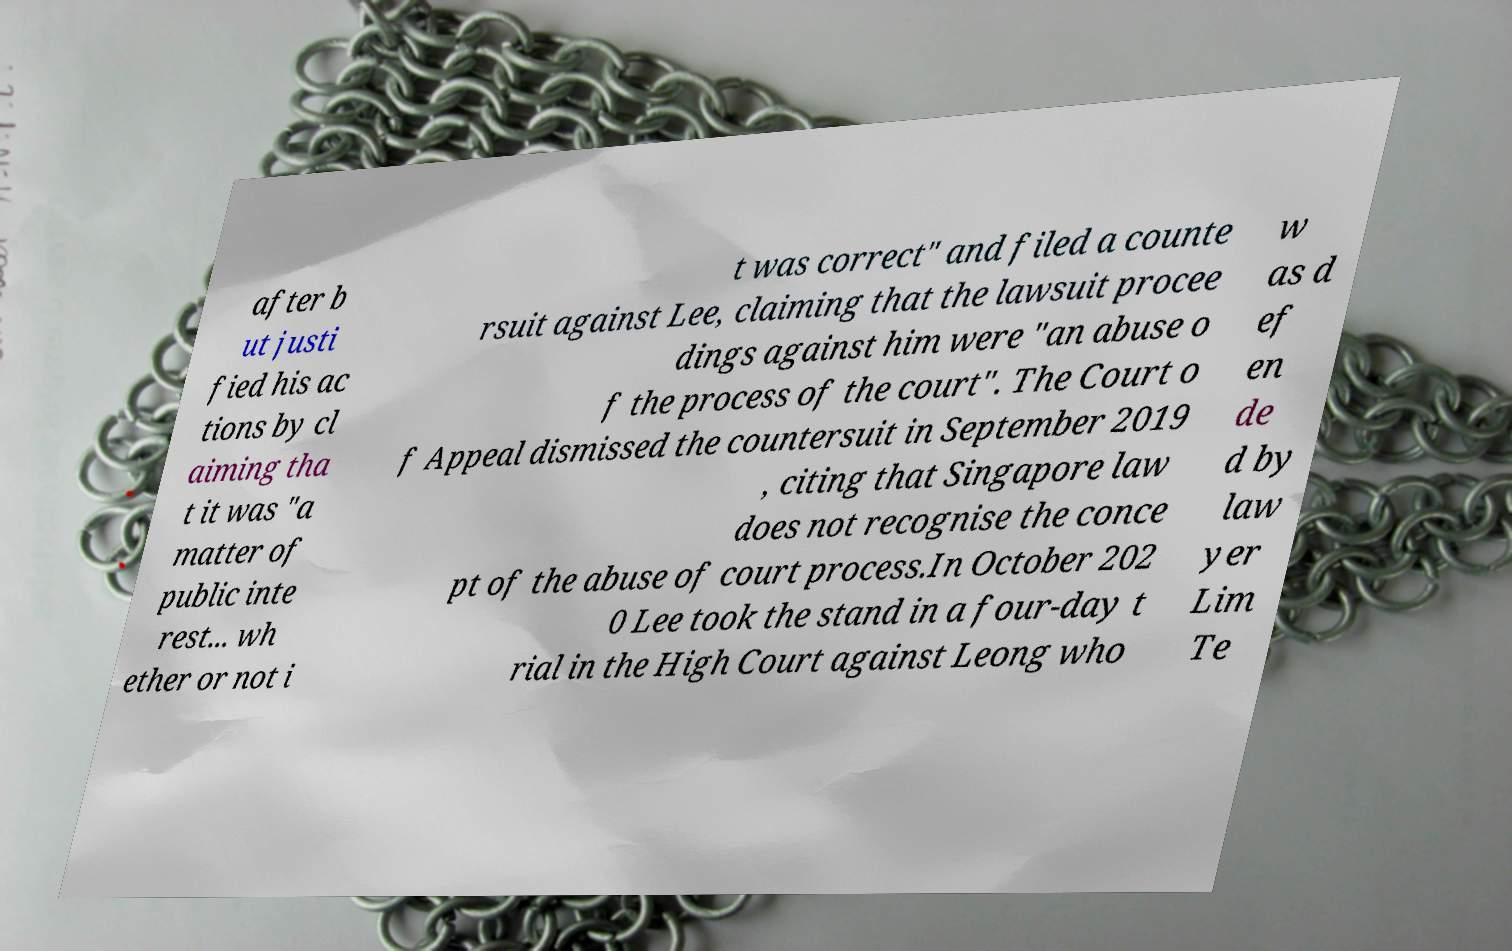For documentation purposes, I need the text within this image transcribed. Could you provide that? after b ut justi fied his ac tions by cl aiming tha t it was "a matter of public inte rest... wh ether or not i t was correct" and filed a counte rsuit against Lee, claiming that the lawsuit procee dings against him were "an abuse o f the process of the court". The Court o f Appeal dismissed the countersuit in September 2019 , citing that Singapore law does not recognise the conce pt of the abuse of court process.In October 202 0 Lee took the stand in a four-day t rial in the High Court against Leong who w as d ef en de d by law yer Lim Te 